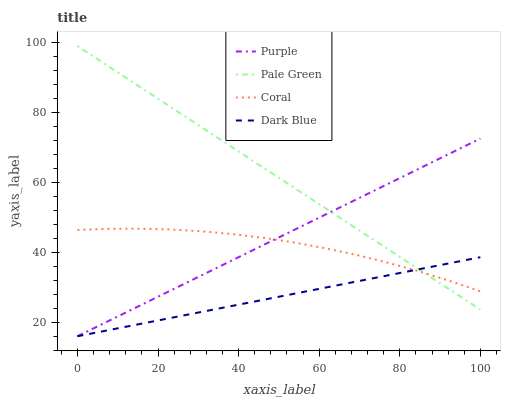Does Dark Blue have the minimum area under the curve?
Answer yes or no. Yes. Does Pale Green have the maximum area under the curve?
Answer yes or no. Yes. Does Coral have the minimum area under the curve?
Answer yes or no. No. Does Coral have the maximum area under the curve?
Answer yes or no. No. Is Dark Blue the smoothest?
Answer yes or no. Yes. Is Coral the roughest?
Answer yes or no. Yes. Is Coral the smoothest?
Answer yes or no. No. Is Dark Blue the roughest?
Answer yes or no. No. Does Purple have the lowest value?
Answer yes or no. Yes. Does Coral have the lowest value?
Answer yes or no. No. Does Pale Green have the highest value?
Answer yes or no. Yes. Does Coral have the highest value?
Answer yes or no. No. Does Dark Blue intersect Purple?
Answer yes or no. Yes. Is Dark Blue less than Purple?
Answer yes or no. No. Is Dark Blue greater than Purple?
Answer yes or no. No. 